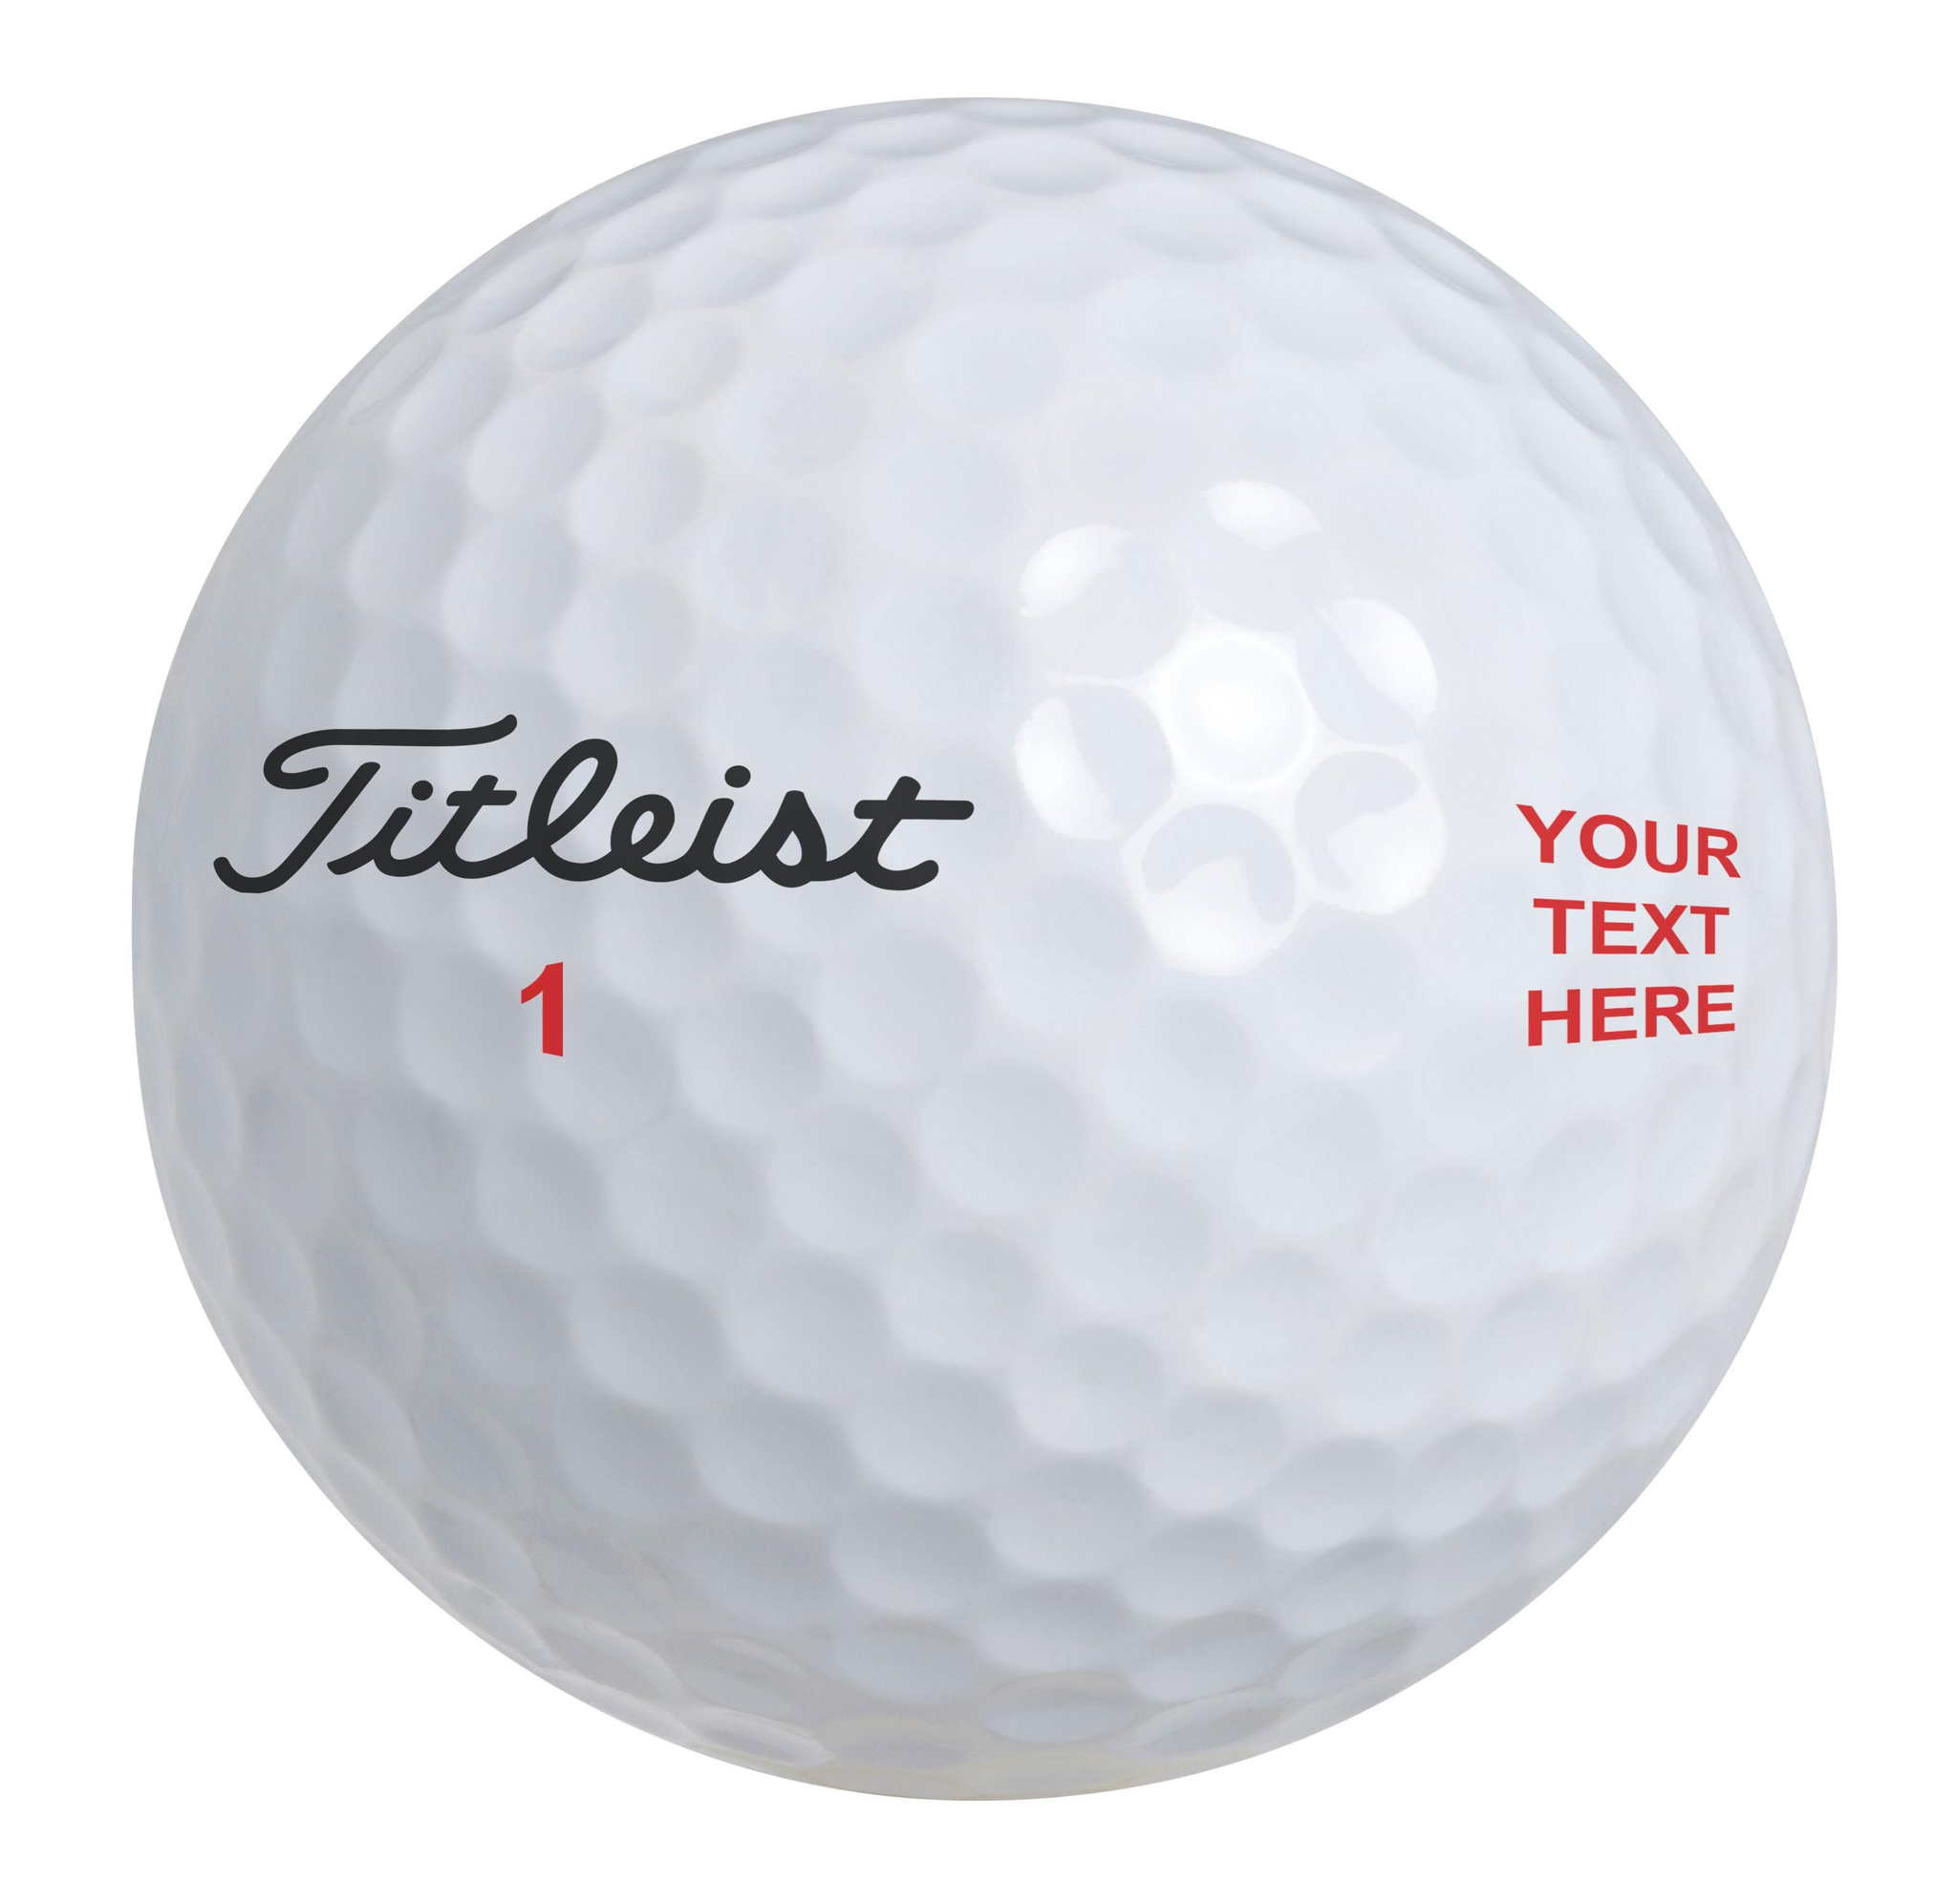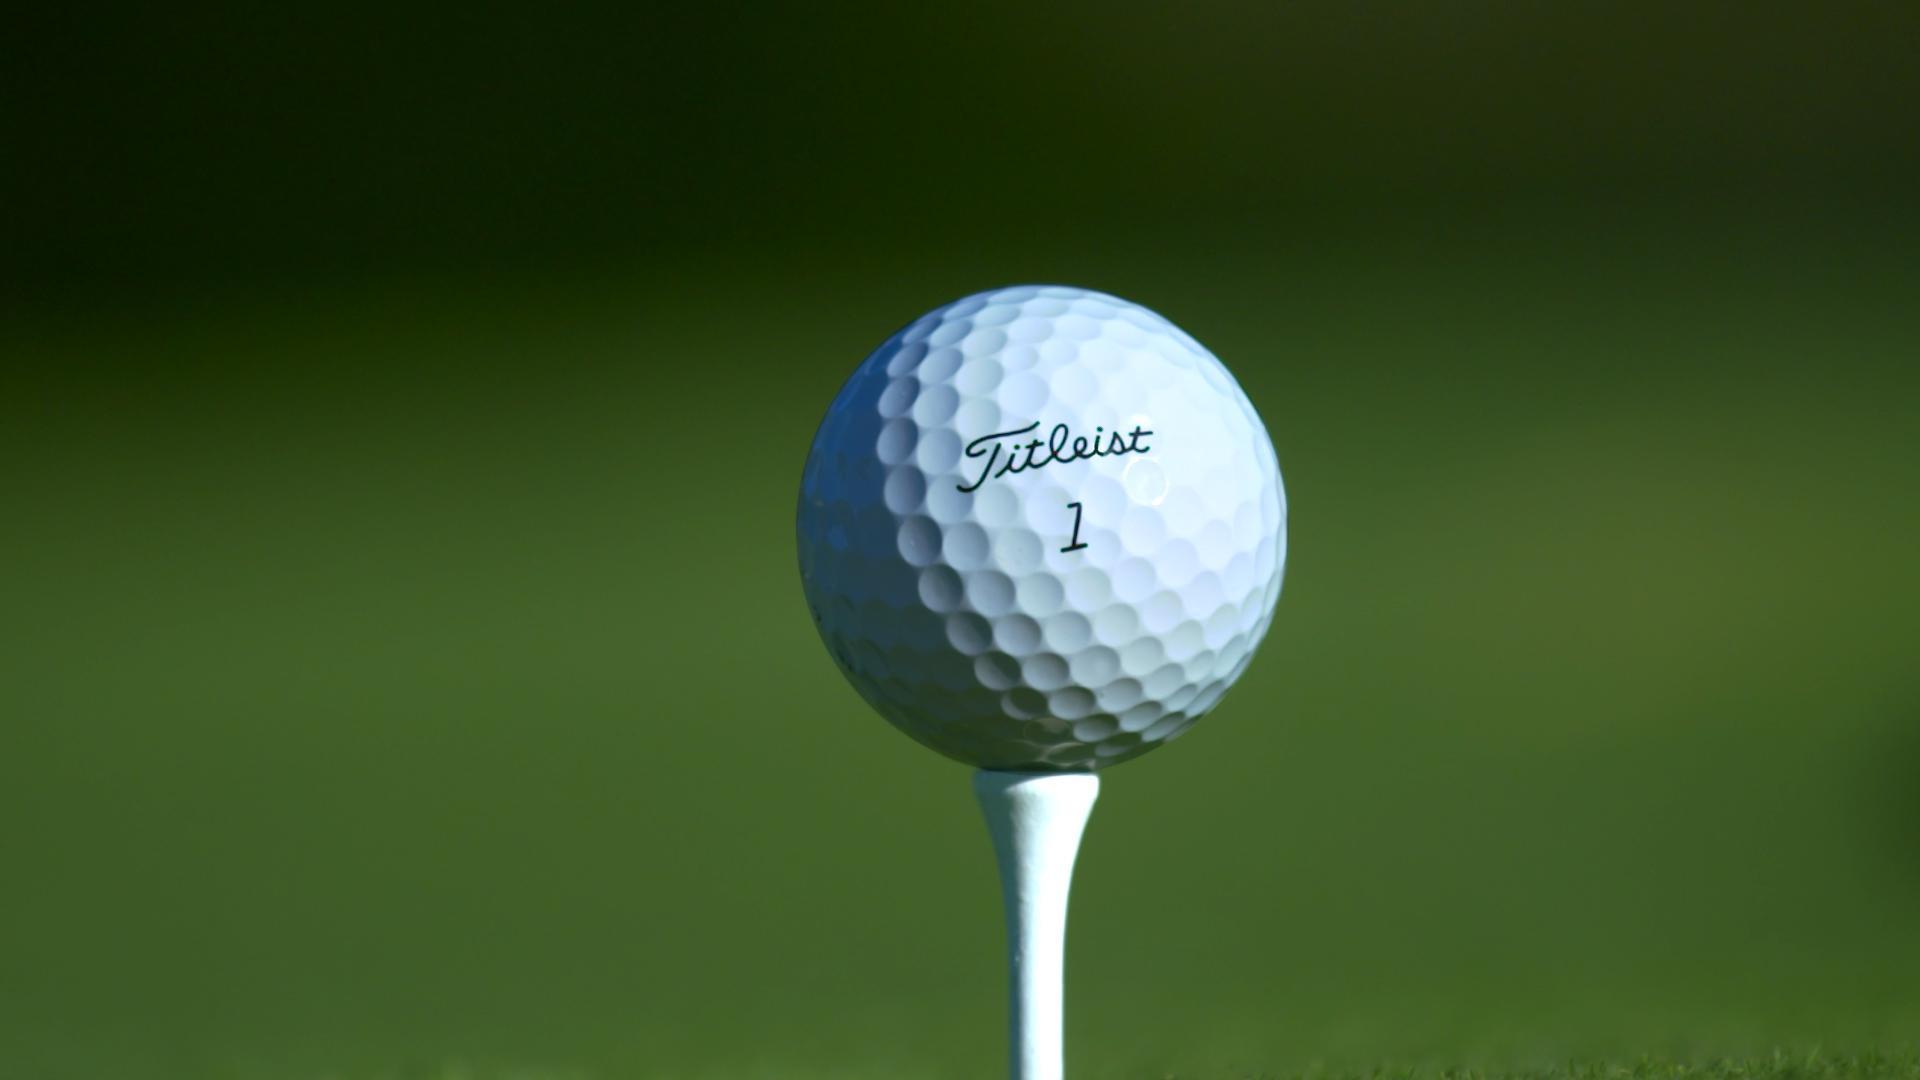The first image is the image on the left, the second image is the image on the right. Examine the images to the left and right. Is the description "There is not less than one golf ball resting on a tee" accurate? Answer yes or no. Yes. 